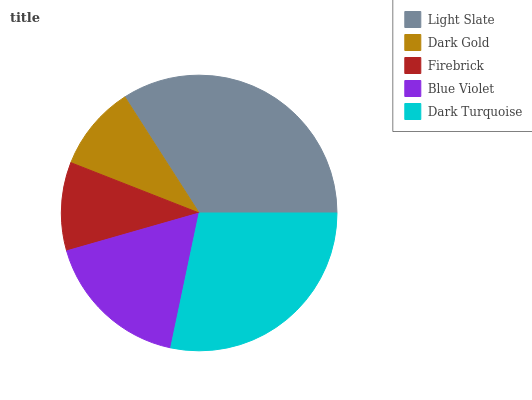Is Dark Gold the minimum?
Answer yes or no. Yes. Is Light Slate the maximum?
Answer yes or no. Yes. Is Firebrick the minimum?
Answer yes or no. No. Is Firebrick the maximum?
Answer yes or no. No. Is Firebrick greater than Dark Gold?
Answer yes or no. Yes. Is Dark Gold less than Firebrick?
Answer yes or no. Yes. Is Dark Gold greater than Firebrick?
Answer yes or no. No. Is Firebrick less than Dark Gold?
Answer yes or no. No. Is Blue Violet the high median?
Answer yes or no. Yes. Is Blue Violet the low median?
Answer yes or no. Yes. Is Firebrick the high median?
Answer yes or no. No. Is Dark Turquoise the low median?
Answer yes or no. No. 